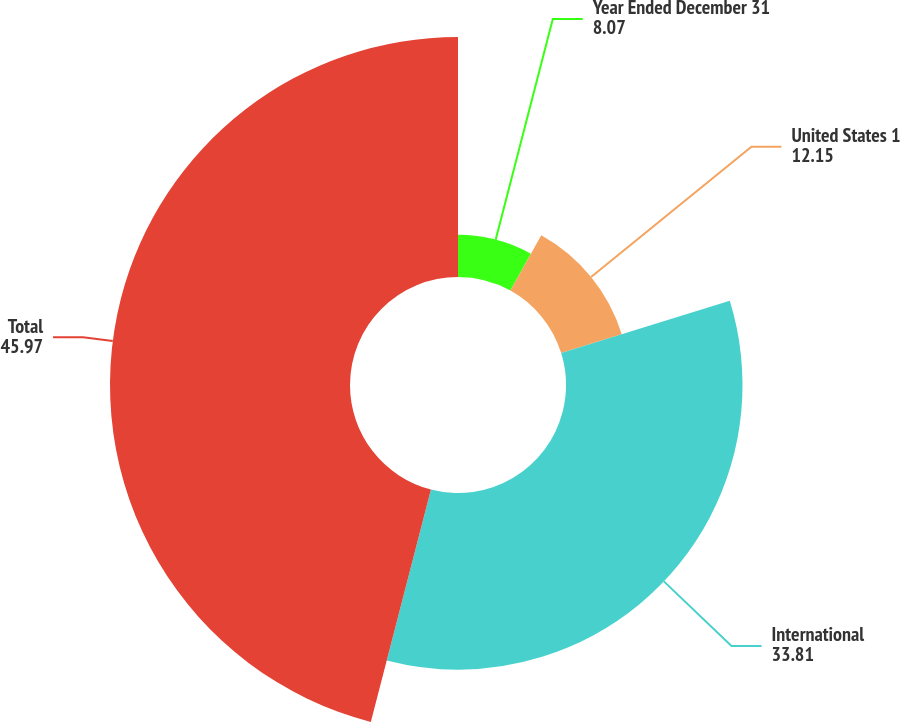Convert chart to OTSL. <chart><loc_0><loc_0><loc_500><loc_500><pie_chart><fcel>Year Ended December 31<fcel>United States 1<fcel>International<fcel>Total<nl><fcel>8.07%<fcel>12.15%<fcel>33.81%<fcel>45.97%<nl></chart> 